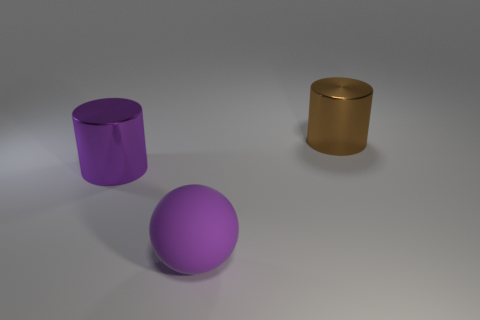Add 2 red rubber objects. How many objects exist? 5 Subtract all spheres. How many objects are left? 2 Add 2 large brown metallic things. How many large brown metallic things are left? 3 Add 1 big rubber objects. How many big rubber objects exist? 2 Subtract 1 brown cylinders. How many objects are left? 2 Subtract all yellow cylinders. Subtract all purple cubes. How many cylinders are left? 2 Subtract all big cylinders. Subtract all large brown metallic things. How many objects are left? 0 